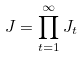<formula> <loc_0><loc_0><loc_500><loc_500>J = \prod _ { t = 1 } ^ { \infty } J _ { t }</formula> 